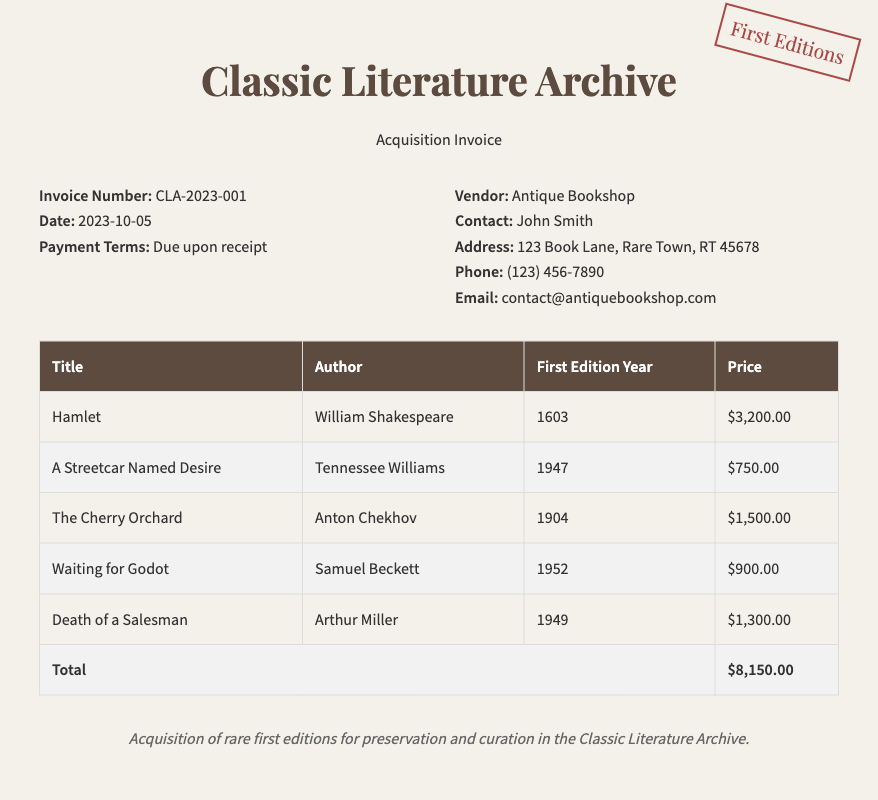what is the invoice number? The invoice number is specified under the invoice details section as "CLA-2023-001."
Answer: CLA-2023-001 who is the vendor? The vendor's name is listed in the document under the vendor section.
Answer: Antique Bookshop what is the total price for the acquisition? The total price is calculated at the bottom of the table, totaling all individual prices listed.
Answer: $8,150.00 which play's first edition year is 1947? The play's first edition year is found in the table that lists the titles and their corresponding years.
Answer: A Streetcar Named Desire who authored "Waiting for Godot"? The author of "Waiting for Godot" is specified in the authors column of the table.
Answer: Samuel Beckett how many classic plays are listed in the invoice? The number of classic plays can be counted in the table that provides details for each item listed.
Answer: 5 what is the price of "Death of a Salesman"? The price for "Death of a Salesman" is mentioned in the table corresponding to the title.
Answer: $1,300.00 what are the payment terms mentioned in the invoice? The payment terms can be found under the invoice details section of the document.
Answer: Due upon receipt 